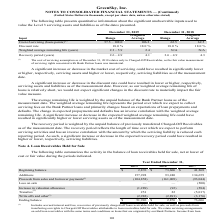From Greensky's financial document, Which years does the table show? The document contains multiple relevant values: 2019, 2018, 2017. From the document: "Year Ended December 31, 2019 2018 2017 Beginning balance $ 2,876 $ 73,606 $ 41,268 Additions 157,928 93,240 134,659 Year Ended December 31, 2019 2018 ..." Also, What were the additions in 2018? According to the financial document, 93,240 (in thousands). The relevant text states: "lance $ 2,876 $ 73,606 $ 41,268 Additions 157,928 93,240 134,659..." Also, What was the loss on sale in 2017? According to the financial document, (500) (in thousands). The relevant text states: "(1) (104,858) (161,009) (93,044) Loss on sale — — (500) Increase in valuation allowance (1,289) (92) (584) Transfers (2) 251 22 (5,017) Write offs and other..." Also, How many years did additions exceed $100,000 thousand? Counting the relevant items in the document: 2019, 2017, I find 2 instances. The key data points involved are: 2017, 2019. Also, can you calculate: What was the change in the ending balance between 2017 and 2019? Based on the calculation: 51,926-73,606, the result is -21680 (in thousands). This is based on the information: "ther (3) (2,982) (2,891) (3,176) Ending balance $ 51,926 $ 2,876 $ 73,606 er 31, 2019 2018 2017 Beginning balance $ 2,876 $ 73,606 $ 41,268 Additions 157,928 93,240 134,659..." The key data points involved are: 51,926, 73,606. Also, can you calculate: What was the percentage change in the Write offs and other between 2018 and 2019? To answer this question, I need to perform calculations using the financial data. The calculation is: (-2,982-(-2,891))/-2,891, which equals 3.15 (percentage). This is based on the information: "251 22 (5,017) Write offs and other (3) (2,982) (2,891) (3,176) Ending balance $ 51,926 $ 2,876 $ 73,606 fers (2) 251 22 (5,017) Write offs and other (3) (2,982) (2,891) (3,176) Ending balance $ 51,92..." The key data points involved are: 2,891, 2,982. 